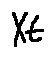Convert formula to latex. <formula><loc_0><loc_0><loc_500><loc_500>X t</formula> 